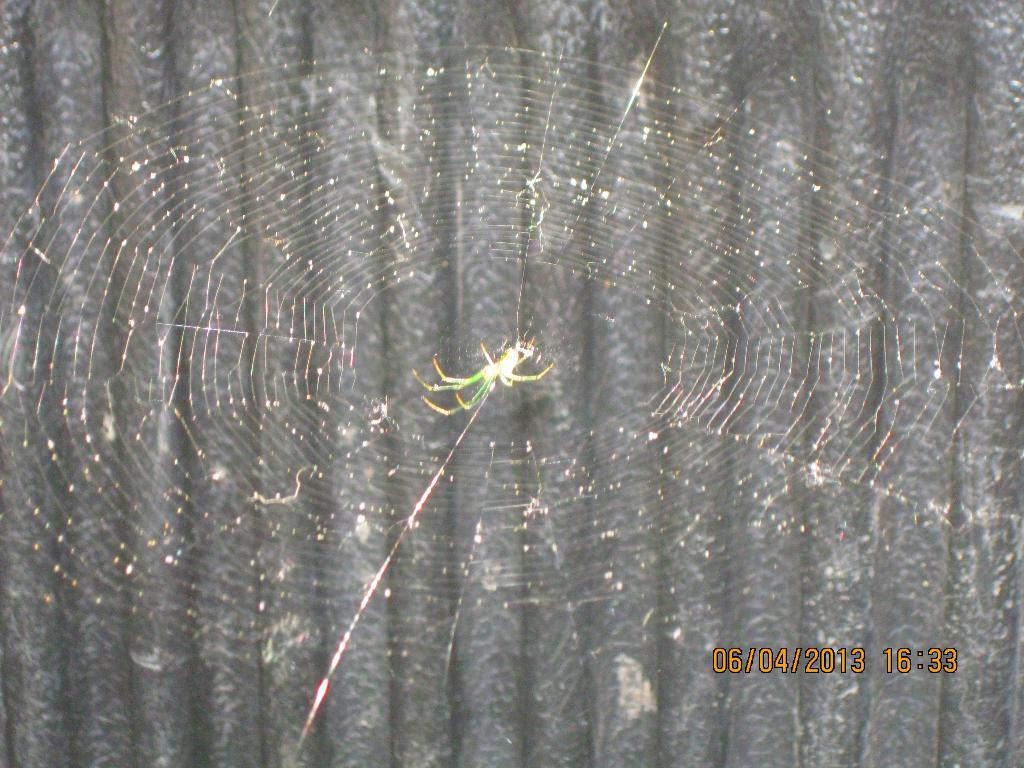What is the main subject of the image? There is a spider in the middle of the image. What is the spider connected to in the image? There is a spider web present in the image, and the spider web is spread around the spider. What can be seen in the background of the image? There is a wall visible in the background of the image. What type of gun is the spider holding in the image? There is no gun present in the image; it features a spider and a spider web. What color is the gold spider in the image? There is no gold spider present in the image; the spider is not described as being gold. 